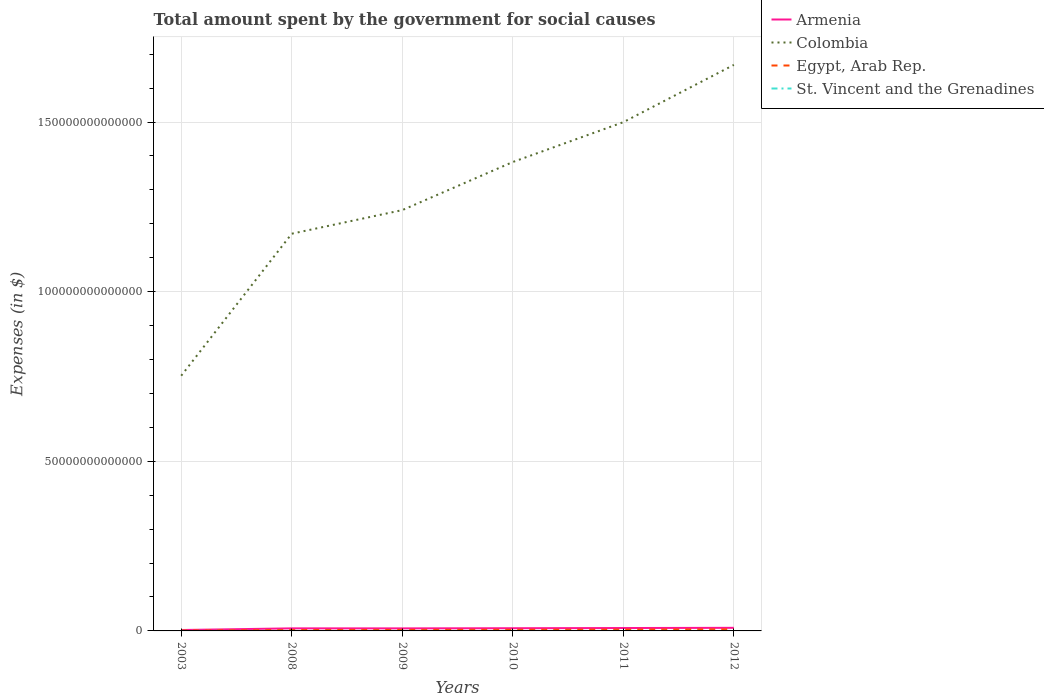Does the line corresponding to Egypt, Arab Rep. intersect with the line corresponding to Armenia?
Provide a succinct answer. No. Is the number of lines equal to the number of legend labels?
Provide a succinct answer. Yes. Across all years, what is the maximum amount spent for social causes by the government in St. Vincent and the Grenadines?
Your response must be concise. 2.72e+08. In which year was the amount spent for social causes by the government in Colombia maximum?
Your answer should be compact. 2003. What is the total amount spent for social causes by the government in Colombia in the graph?
Offer a terse response. -3.29e+13. What is the difference between the highest and the second highest amount spent for social causes by the government in Colombia?
Your answer should be very brief. 9.16e+13. How many lines are there?
Provide a succinct answer. 4. What is the difference between two consecutive major ticks on the Y-axis?
Your response must be concise. 5.00e+13. Does the graph contain grids?
Your answer should be very brief. Yes. Where does the legend appear in the graph?
Provide a succinct answer. Top right. How are the legend labels stacked?
Ensure brevity in your answer.  Vertical. What is the title of the graph?
Provide a short and direct response. Total amount spent by the government for social causes. What is the label or title of the Y-axis?
Ensure brevity in your answer.  Expenses (in $). What is the Expenses (in $) of Armenia in 2003?
Your answer should be compact. 2.67e+11. What is the Expenses (in $) in Colombia in 2003?
Ensure brevity in your answer.  7.52e+13. What is the Expenses (in $) of Egypt, Arab Rep. in 2003?
Offer a very short reply. 1.14e+11. What is the Expenses (in $) in St. Vincent and the Grenadines in 2003?
Provide a succinct answer. 2.72e+08. What is the Expenses (in $) of Armenia in 2008?
Give a very brief answer. 7.54e+11. What is the Expenses (in $) of Colombia in 2008?
Your answer should be compact. 1.17e+14. What is the Expenses (in $) of Egypt, Arab Rep. in 2008?
Make the answer very short. 2.71e+11. What is the Expenses (in $) of St. Vincent and the Grenadines in 2008?
Ensure brevity in your answer.  4.31e+08. What is the Expenses (in $) of Armenia in 2009?
Give a very brief answer. 7.50e+11. What is the Expenses (in $) in Colombia in 2009?
Your answer should be compact. 1.24e+14. What is the Expenses (in $) in Egypt, Arab Rep. in 2009?
Ensure brevity in your answer.  3.13e+11. What is the Expenses (in $) of St. Vincent and the Grenadines in 2009?
Your answer should be compact. 4.70e+08. What is the Expenses (in $) in Armenia in 2010?
Your answer should be very brief. 7.96e+11. What is the Expenses (in $) of Colombia in 2010?
Ensure brevity in your answer.  1.38e+14. What is the Expenses (in $) of Egypt, Arab Rep. in 2010?
Your answer should be compact. 3.48e+11. What is the Expenses (in $) in St. Vincent and the Grenadines in 2010?
Offer a very short reply. 4.73e+08. What is the Expenses (in $) in Armenia in 2011?
Provide a succinct answer. 8.53e+11. What is the Expenses (in $) in Colombia in 2011?
Your answer should be compact. 1.50e+14. What is the Expenses (in $) of Egypt, Arab Rep. in 2011?
Offer a very short reply. 4.00e+11. What is the Expenses (in $) in St. Vincent and the Grenadines in 2011?
Your answer should be compact. 4.95e+08. What is the Expenses (in $) in Armenia in 2012?
Make the answer very short. 9.12e+11. What is the Expenses (in $) in Colombia in 2012?
Offer a terse response. 1.67e+14. What is the Expenses (in $) in Egypt, Arab Rep. in 2012?
Offer a terse response. 4.80e+11. What is the Expenses (in $) of St. Vincent and the Grenadines in 2012?
Give a very brief answer. 4.89e+08. Across all years, what is the maximum Expenses (in $) in Armenia?
Offer a very short reply. 9.12e+11. Across all years, what is the maximum Expenses (in $) of Colombia?
Your answer should be very brief. 1.67e+14. Across all years, what is the maximum Expenses (in $) of Egypt, Arab Rep.?
Your answer should be very brief. 4.80e+11. Across all years, what is the maximum Expenses (in $) in St. Vincent and the Grenadines?
Provide a succinct answer. 4.95e+08. Across all years, what is the minimum Expenses (in $) in Armenia?
Make the answer very short. 2.67e+11. Across all years, what is the minimum Expenses (in $) of Colombia?
Offer a very short reply. 7.52e+13. Across all years, what is the minimum Expenses (in $) of Egypt, Arab Rep.?
Offer a very short reply. 1.14e+11. Across all years, what is the minimum Expenses (in $) of St. Vincent and the Grenadines?
Provide a succinct answer. 2.72e+08. What is the total Expenses (in $) of Armenia in the graph?
Offer a very short reply. 4.33e+12. What is the total Expenses (in $) of Colombia in the graph?
Provide a succinct answer. 7.71e+14. What is the total Expenses (in $) of Egypt, Arab Rep. in the graph?
Your answer should be very brief. 1.93e+12. What is the total Expenses (in $) in St. Vincent and the Grenadines in the graph?
Offer a terse response. 2.63e+09. What is the difference between the Expenses (in $) of Armenia in 2003 and that in 2008?
Your response must be concise. -4.88e+11. What is the difference between the Expenses (in $) in Colombia in 2003 and that in 2008?
Your response must be concise. -4.19e+13. What is the difference between the Expenses (in $) in Egypt, Arab Rep. in 2003 and that in 2008?
Offer a terse response. -1.57e+11. What is the difference between the Expenses (in $) of St. Vincent and the Grenadines in 2003 and that in 2008?
Provide a short and direct response. -1.58e+08. What is the difference between the Expenses (in $) in Armenia in 2003 and that in 2009?
Keep it short and to the point. -4.83e+11. What is the difference between the Expenses (in $) of Colombia in 2003 and that in 2009?
Keep it short and to the point. -4.88e+13. What is the difference between the Expenses (in $) of Egypt, Arab Rep. in 2003 and that in 2009?
Offer a terse response. -1.99e+11. What is the difference between the Expenses (in $) of St. Vincent and the Grenadines in 2003 and that in 2009?
Make the answer very short. -1.97e+08. What is the difference between the Expenses (in $) of Armenia in 2003 and that in 2010?
Your response must be concise. -5.29e+11. What is the difference between the Expenses (in $) of Colombia in 2003 and that in 2010?
Make the answer very short. -6.30e+13. What is the difference between the Expenses (in $) in Egypt, Arab Rep. in 2003 and that in 2010?
Offer a terse response. -2.34e+11. What is the difference between the Expenses (in $) of St. Vincent and the Grenadines in 2003 and that in 2010?
Provide a short and direct response. -2.01e+08. What is the difference between the Expenses (in $) of Armenia in 2003 and that in 2011?
Offer a terse response. -5.86e+11. What is the difference between the Expenses (in $) of Colombia in 2003 and that in 2011?
Offer a very short reply. -7.47e+13. What is the difference between the Expenses (in $) of Egypt, Arab Rep. in 2003 and that in 2011?
Make the answer very short. -2.86e+11. What is the difference between the Expenses (in $) in St. Vincent and the Grenadines in 2003 and that in 2011?
Give a very brief answer. -2.23e+08. What is the difference between the Expenses (in $) in Armenia in 2003 and that in 2012?
Provide a succinct answer. -6.45e+11. What is the difference between the Expenses (in $) of Colombia in 2003 and that in 2012?
Keep it short and to the point. -9.16e+13. What is the difference between the Expenses (in $) in Egypt, Arab Rep. in 2003 and that in 2012?
Keep it short and to the point. -3.66e+11. What is the difference between the Expenses (in $) in St. Vincent and the Grenadines in 2003 and that in 2012?
Make the answer very short. -2.16e+08. What is the difference between the Expenses (in $) of Armenia in 2008 and that in 2009?
Provide a succinct answer. 4.65e+09. What is the difference between the Expenses (in $) of Colombia in 2008 and that in 2009?
Keep it short and to the point. -6.96e+12. What is the difference between the Expenses (in $) in Egypt, Arab Rep. in 2008 and that in 2009?
Give a very brief answer. -4.20e+1. What is the difference between the Expenses (in $) of St. Vincent and the Grenadines in 2008 and that in 2009?
Your answer should be compact. -3.90e+07. What is the difference between the Expenses (in $) in Armenia in 2008 and that in 2010?
Ensure brevity in your answer.  -4.14e+1. What is the difference between the Expenses (in $) in Colombia in 2008 and that in 2010?
Offer a very short reply. -2.11e+13. What is the difference between the Expenses (in $) in Egypt, Arab Rep. in 2008 and that in 2010?
Keep it short and to the point. -7.67e+1. What is the difference between the Expenses (in $) in St. Vincent and the Grenadines in 2008 and that in 2010?
Give a very brief answer. -4.24e+07. What is the difference between the Expenses (in $) of Armenia in 2008 and that in 2011?
Your response must be concise. -9.83e+1. What is the difference between the Expenses (in $) of Colombia in 2008 and that in 2011?
Offer a very short reply. -3.29e+13. What is the difference between the Expenses (in $) of Egypt, Arab Rep. in 2008 and that in 2011?
Your response must be concise. -1.29e+11. What is the difference between the Expenses (in $) in St. Vincent and the Grenadines in 2008 and that in 2011?
Give a very brief answer. -6.44e+07. What is the difference between the Expenses (in $) of Armenia in 2008 and that in 2012?
Ensure brevity in your answer.  -1.58e+11. What is the difference between the Expenses (in $) of Colombia in 2008 and that in 2012?
Your response must be concise. -4.98e+13. What is the difference between the Expenses (in $) of Egypt, Arab Rep. in 2008 and that in 2012?
Make the answer very short. -2.09e+11. What is the difference between the Expenses (in $) of St. Vincent and the Grenadines in 2008 and that in 2012?
Make the answer very short. -5.81e+07. What is the difference between the Expenses (in $) of Armenia in 2009 and that in 2010?
Provide a short and direct response. -4.61e+1. What is the difference between the Expenses (in $) of Colombia in 2009 and that in 2010?
Your response must be concise. -1.42e+13. What is the difference between the Expenses (in $) in Egypt, Arab Rep. in 2009 and that in 2010?
Provide a succinct answer. -3.48e+1. What is the difference between the Expenses (in $) in St. Vincent and the Grenadines in 2009 and that in 2010?
Keep it short and to the point. -3.40e+06. What is the difference between the Expenses (in $) of Armenia in 2009 and that in 2011?
Provide a succinct answer. -1.03e+11. What is the difference between the Expenses (in $) in Colombia in 2009 and that in 2011?
Ensure brevity in your answer.  -2.59e+13. What is the difference between the Expenses (in $) in Egypt, Arab Rep. in 2009 and that in 2011?
Your answer should be very brief. -8.68e+1. What is the difference between the Expenses (in $) in St. Vincent and the Grenadines in 2009 and that in 2011?
Your answer should be compact. -2.54e+07. What is the difference between the Expenses (in $) of Armenia in 2009 and that in 2012?
Offer a terse response. -1.62e+11. What is the difference between the Expenses (in $) in Colombia in 2009 and that in 2012?
Your response must be concise. -4.28e+13. What is the difference between the Expenses (in $) of Egypt, Arab Rep. in 2009 and that in 2012?
Give a very brief answer. -1.67e+11. What is the difference between the Expenses (in $) in St. Vincent and the Grenadines in 2009 and that in 2012?
Make the answer very short. -1.91e+07. What is the difference between the Expenses (in $) of Armenia in 2010 and that in 2011?
Your answer should be very brief. -5.69e+1. What is the difference between the Expenses (in $) of Colombia in 2010 and that in 2011?
Offer a terse response. -1.17e+13. What is the difference between the Expenses (in $) of Egypt, Arab Rep. in 2010 and that in 2011?
Offer a very short reply. -5.20e+1. What is the difference between the Expenses (in $) of St. Vincent and the Grenadines in 2010 and that in 2011?
Ensure brevity in your answer.  -2.20e+07. What is the difference between the Expenses (in $) in Armenia in 2010 and that in 2012?
Your answer should be very brief. -1.16e+11. What is the difference between the Expenses (in $) of Colombia in 2010 and that in 2012?
Give a very brief answer. -2.86e+13. What is the difference between the Expenses (in $) in Egypt, Arab Rep. in 2010 and that in 2012?
Your response must be concise. -1.32e+11. What is the difference between the Expenses (in $) in St. Vincent and the Grenadines in 2010 and that in 2012?
Your answer should be very brief. -1.57e+07. What is the difference between the Expenses (in $) of Armenia in 2011 and that in 2012?
Provide a succinct answer. -5.93e+1. What is the difference between the Expenses (in $) of Colombia in 2011 and that in 2012?
Your response must be concise. -1.69e+13. What is the difference between the Expenses (in $) of Egypt, Arab Rep. in 2011 and that in 2012?
Your answer should be very brief. -8.02e+1. What is the difference between the Expenses (in $) in St. Vincent and the Grenadines in 2011 and that in 2012?
Offer a terse response. 6.30e+06. What is the difference between the Expenses (in $) in Armenia in 2003 and the Expenses (in $) in Colombia in 2008?
Your response must be concise. -1.17e+14. What is the difference between the Expenses (in $) in Armenia in 2003 and the Expenses (in $) in Egypt, Arab Rep. in 2008?
Your response must be concise. -4.82e+09. What is the difference between the Expenses (in $) of Armenia in 2003 and the Expenses (in $) of St. Vincent and the Grenadines in 2008?
Your answer should be compact. 2.66e+11. What is the difference between the Expenses (in $) in Colombia in 2003 and the Expenses (in $) in Egypt, Arab Rep. in 2008?
Keep it short and to the point. 7.50e+13. What is the difference between the Expenses (in $) in Colombia in 2003 and the Expenses (in $) in St. Vincent and the Grenadines in 2008?
Provide a succinct answer. 7.52e+13. What is the difference between the Expenses (in $) of Egypt, Arab Rep. in 2003 and the Expenses (in $) of St. Vincent and the Grenadines in 2008?
Offer a very short reply. 1.14e+11. What is the difference between the Expenses (in $) in Armenia in 2003 and the Expenses (in $) in Colombia in 2009?
Your answer should be compact. -1.24e+14. What is the difference between the Expenses (in $) of Armenia in 2003 and the Expenses (in $) of Egypt, Arab Rep. in 2009?
Ensure brevity in your answer.  -4.68e+1. What is the difference between the Expenses (in $) in Armenia in 2003 and the Expenses (in $) in St. Vincent and the Grenadines in 2009?
Provide a short and direct response. 2.66e+11. What is the difference between the Expenses (in $) in Colombia in 2003 and the Expenses (in $) in Egypt, Arab Rep. in 2009?
Give a very brief answer. 7.49e+13. What is the difference between the Expenses (in $) of Colombia in 2003 and the Expenses (in $) of St. Vincent and the Grenadines in 2009?
Offer a terse response. 7.52e+13. What is the difference between the Expenses (in $) in Egypt, Arab Rep. in 2003 and the Expenses (in $) in St. Vincent and the Grenadines in 2009?
Make the answer very short. 1.14e+11. What is the difference between the Expenses (in $) of Armenia in 2003 and the Expenses (in $) of Colombia in 2010?
Your answer should be very brief. -1.38e+14. What is the difference between the Expenses (in $) in Armenia in 2003 and the Expenses (in $) in Egypt, Arab Rep. in 2010?
Provide a short and direct response. -8.15e+1. What is the difference between the Expenses (in $) in Armenia in 2003 and the Expenses (in $) in St. Vincent and the Grenadines in 2010?
Make the answer very short. 2.66e+11. What is the difference between the Expenses (in $) of Colombia in 2003 and the Expenses (in $) of Egypt, Arab Rep. in 2010?
Provide a succinct answer. 7.49e+13. What is the difference between the Expenses (in $) in Colombia in 2003 and the Expenses (in $) in St. Vincent and the Grenadines in 2010?
Provide a succinct answer. 7.52e+13. What is the difference between the Expenses (in $) of Egypt, Arab Rep. in 2003 and the Expenses (in $) of St. Vincent and the Grenadines in 2010?
Provide a succinct answer. 1.14e+11. What is the difference between the Expenses (in $) in Armenia in 2003 and the Expenses (in $) in Colombia in 2011?
Provide a succinct answer. -1.50e+14. What is the difference between the Expenses (in $) in Armenia in 2003 and the Expenses (in $) in Egypt, Arab Rep. in 2011?
Your response must be concise. -1.34e+11. What is the difference between the Expenses (in $) of Armenia in 2003 and the Expenses (in $) of St. Vincent and the Grenadines in 2011?
Offer a very short reply. 2.66e+11. What is the difference between the Expenses (in $) of Colombia in 2003 and the Expenses (in $) of Egypt, Arab Rep. in 2011?
Ensure brevity in your answer.  7.48e+13. What is the difference between the Expenses (in $) of Colombia in 2003 and the Expenses (in $) of St. Vincent and the Grenadines in 2011?
Your answer should be compact. 7.52e+13. What is the difference between the Expenses (in $) in Egypt, Arab Rep. in 2003 and the Expenses (in $) in St. Vincent and the Grenadines in 2011?
Your response must be concise. 1.14e+11. What is the difference between the Expenses (in $) in Armenia in 2003 and the Expenses (in $) in Colombia in 2012?
Provide a succinct answer. -1.67e+14. What is the difference between the Expenses (in $) in Armenia in 2003 and the Expenses (in $) in Egypt, Arab Rep. in 2012?
Give a very brief answer. -2.14e+11. What is the difference between the Expenses (in $) of Armenia in 2003 and the Expenses (in $) of St. Vincent and the Grenadines in 2012?
Your response must be concise. 2.66e+11. What is the difference between the Expenses (in $) in Colombia in 2003 and the Expenses (in $) in Egypt, Arab Rep. in 2012?
Make the answer very short. 7.47e+13. What is the difference between the Expenses (in $) in Colombia in 2003 and the Expenses (in $) in St. Vincent and the Grenadines in 2012?
Ensure brevity in your answer.  7.52e+13. What is the difference between the Expenses (in $) of Egypt, Arab Rep. in 2003 and the Expenses (in $) of St. Vincent and the Grenadines in 2012?
Offer a very short reply. 1.14e+11. What is the difference between the Expenses (in $) in Armenia in 2008 and the Expenses (in $) in Colombia in 2009?
Your answer should be very brief. -1.23e+14. What is the difference between the Expenses (in $) in Armenia in 2008 and the Expenses (in $) in Egypt, Arab Rep. in 2009?
Provide a short and direct response. 4.41e+11. What is the difference between the Expenses (in $) in Armenia in 2008 and the Expenses (in $) in St. Vincent and the Grenadines in 2009?
Make the answer very short. 7.54e+11. What is the difference between the Expenses (in $) of Colombia in 2008 and the Expenses (in $) of Egypt, Arab Rep. in 2009?
Keep it short and to the point. 1.17e+14. What is the difference between the Expenses (in $) in Colombia in 2008 and the Expenses (in $) in St. Vincent and the Grenadines in 2009?
Provide a short and direct response. 1.17e+14. What is the difference between the Expenses (in $) of Egypt, Arab Rep. in 2008 and the Expenses (in $) of St. Vincent and the Grenadines in 2009?
Offer a terse response. 2.71e+11. What is the difference between the Expenses (in $) in Armenia in 2008 and the Expenses (in $) in Colombia in 2010?
Offer a terse response. -1.37e+14. What is the difference between the Expenses (in $) in Armenia in 2008 and the Expenses (in $) in Egypt, Arab Rep. in 2010?
Keep it short and to the point. 4.06e+11. What is the difference between the Expenses (in $) in Armenia in 2008 and the Expenses (in $) in St. Vincent and the Grenadines in 2010?
Your answer should be very brief. 7.54e+11. What is the difference between the Expenses (in $) in Colombia in 2008 and the Expenses (in $) in Egypt, Arab Rep. in 2010?
Provide a short and direct response. 1.17e+14. What is the difference between the Expenses (in $) in Colombia in 2008 and the Expenses (in $) in St. Vincent and the Grenadines in 2010?
Your answer should be very brief. 1.17e+14. What is the difference between the Expenses (in $) of Egypt, Arab Rep. in 2008 and the Expenses (in $) of St. Vincent and the Grenadines in 2010?
Provide a succinct answer. 2.71e+11. What is the difference between the Expenses (in $) in Armenia in 2008 and the Expenses (in $) in Colombia in 2011?
Keep it short and to the point. -1.49e+14. What is the difference between the Expenses (in $) in Armenia in 2008 and the Expenses (in $) in Egypt, Arab Rep. in 2011?
Provide a succinct answer. 3.54e+11. What is the difference between the Expenses (in $) of Armenia in 2008 and the Expenses (in $) of St. Vincent and the Grenadines in 2011?
Your response must be concise. 7.54e+11. What is the difference between the Expenses (in $) in Colombia in 2008 and the Expenses (in $) in Egypt, Arab Rep. in 2011?
Provide a succinct answer. 1.17e+14. What is the difference between the Expenses (in $) of Colombia in 2008 and the Expenses (in $) of St. Vincent and the Grenadines in 2011?
Your answer should be compact. 1.17e+14. What is the difference between the Expenses (in $) in Egypt, Arab Rep. in 2008 and the Expenses (in $) in St. Vincent and the Grenadines in 2011?
Provide a short and direct response. 2.71e+11. What is the difference between the Expenses (in $) of Armenia in 2008 and the Expenses (in $) of Colombia in 2012?
Your answer should be very brief. -1.66e+14. What is the difference between the Expenses (in $) in Armenia in 2008 and the Expenses (in $) in Egypt, Arab Rep. in 2012?
Provide a succinct answer. 2.74e+11. What is the difference between the Expenses (in $) in Armenia in 2008 and the Expenses (in $) in St. Vincent and the Grenadines in 2012?
Keep it short and to the point. 7.54e+11. What is the difference between the Expenses (in $) in Colombia in 2008 and the Expenses (in $) in Egypt, Arab Rep. in 2012?
Your answer should be very brief. 1.17e+14. What is the difference between the Expenses (in $) of Colombia in 2008 and the Expenses (in $) of St. Vincent and the Grenadines in 2012?
Offer a very short reply. 1.17e+14. What is the difference between the Expenses (in $) in Egypt, Arab Rep. in 2008 and the Expenses (in $) in St. Vincent and the Grenadines in 2012?
Provide a short and direct response. 2.71e+11. What is the difference between the Expenses (in $) in Armenia in 2009 and the Expenses (in $) in Colombia in 2010?
Your response must be concise. -1.37e+14. What is the difference between the Expenses (in $) in Armenia in 2009 and the Expenses (in $) in Egypt, Arab Rep. in 2010?
Your answer should be compact. 4.01e+11. What is the difference between the Expenses (in $) of Armenia in 2009 and the Expenses (in $) of St. Vincent and the Grenadines in 2010?
Provide a short and direct response. 7.49e+11. What is the difference between the Expenses (in $) in Colombia in 2009 and the Expenses (in $) in Egypt, Arab Rep. in 2010?
Provide a short and direct response. 1.24e+14. What is the difference between the Expenses (in $) of Colombia in 2009 and the Expenses (in $) of St. Vincent and the Grenadines in 2010?
Provide a succinct answer. 1.24e+14. What is the difference between the Expenses (in $) in Egypt, Arab Rep. in 2009 and the Expenses (in $) in St. Vincent and the Grenadines in 2010?
Give a very brief answer. 3.13e+11. What is the difference between the Expenses (in $) of Armenia in 2009 and the Expenses (in $) of Colombia in 2011?
Offer a very short reply. -1.49e+14. What is the difference between the Expenses (in $) in Armenia in 2009 and the Expenses (in $) in Egypt, Arab Rep. in 2011?
Give a very brief answer. 3.49e+11. What is the difference between the Expenses (in $) of Armenia in 2009 and the Expenses (in $) of St. Vincent and the Grenadines in 2011?
Provide a succinct answer. 7.49e+11. What is the difference between the Expenses (in $) of Colombia in 2009 and the Expenses (in $) of Egypt, Arab Rep. in 2011?
Provide a succinct answer. 1.24e+14. What is the difference between the Expenses (in $) in Colombia in 2009 and the Expenses (in $) in St. Vincent and the Grenadines in 2011?
Keep it short and to the point. 1.24e+14. What is the difference between the Expenses (in $) of Egypt, Arab Rep. in 2009 and the Expenses (in $) of St. Vincent and the Grenadines in 2011?
Your answer should be compact. 3.13e+11. What is the difference between the Expenses (in $) in Armenia in 2009 and the Expenses (in $) in Colombia in 2012?
Your answer should be compact. -1.66e+14. What is the difference between the Expenses (in $) of Armenia in 2009 and the Expenses (in $) of Egypt, Arab Rep. in 2012?
Provide a succinct answer. 2.69e+11. What is the difference between the Expenses (in $) in Armenia in 2009 and the Expenses (in $) in St. Vincent and the Grenadines in 2012?
Your answer should be compact. 7.49e+11. What is the difference between the Expenses (in $) of Colombia in 2009 and the Expenses (in $) of Egypt, Arab Rep. in 2012?
Ensure brevity in your answer.  1.24e+14. What is the difference between the Expenses (in $) in Colombia in 2009 and the Expenses (in $) in St. Vincent and the Grenadines in 2012?
Offer a terse response. 1.24e+14. What is the difference between the Expenses (in $) of Egypt, Arab Rep. in 2009 and the Expenses (in $) of St. Vincent and the Grenadines in 2012?
Your response must be concise. 3.13e+11. What is the difference between the Expenses (in $) of Armenia in 2010 and the Expenses (in $) of Colombia in 2011?
Your answer should be very brief. -1.49e+14. What is the difference between the Expenses (in $) in Armenia in 2010 and the Expenses (in $) in Egypt, Arab Rep. in 2011?
Keep it short and to the point. 3.96e+11. What is the difference between the Expenses (in $) in Armenia in 2010 and the Expenses (in $) in St. Vincent and the Grenadines in 2011?
Keep it short and to the point. 7.95e+11. What is the difference between the Expenses (in $) of Colombia in 2010 and the Expenses (in $) of Egypt, Arab Rep. in 2011?
Make the answer very short. 1.38e+14. What is the difference between the Expenses (in $) in Colombia in 2010 and the Expenses (in $) in St. Vincent and the Grenadines in 2011?
Keep it short and to the point. 1.38e+14. What is the difference between the Expenses (in $) of Egypt, Arab Rep. in 2010 and the Expenses (in $) of St. Vincent and the Grenadines in 2011?
Ensure brevity in your answer.  3.48e+11. What is the difference between the Expenses (in $) of Armenia in 2010 and the Expenses (in $) of Colombia in 2012?
Make the answer very short. -1.66e+14. What is the difference between the Expenses (in $) of Armenia in 2010 and the Expenses (in $) of Egypt, Arab Rep. in 2012?
Offer a terse response. 3.15e+11. What is the difference between the Expenses (in $) of Armenia in 2010 and the Expenses (in $) of St. Vincent and the Grenadines in 2012?
Ensure brevity in your answer.  7.95e+11. What is the difference between the Expenses (in $) of Colombia in 2010 and the Expenses (in $) of Egypt, Arab Rep. in 2012?
Your answer should be compact. 1.38e+14. What is the difference between the Expenses (in $) of Colombia in 2010 and the Expenses (in $) of St. Vincent and the Grenadines in 2012?
Make the answer very short. 1.38e+14. What is the difference between the Expenses (in $) in Egypt, Arab Rep. in 2010 and the Expenses (in $) in St. Vincent and the Grenadines in 2012?
Ensure brevity in your answer.  3.48e+11. What is the difference between the Expenses (in $) of Armenia in 2011 and the Expenses (in $) of Colombia in 2012?
Your answer should be very brief. -1.66e+14. What is the difference between the Expenses (in $) in Armenia in 2011 and the Expenses (in $) in Egypt, Arab Rep. in 2012?
Offer a terse response. 3.72e+11. What is the difference between the Expenses (in $) in Armenia in 2011 and the Expenses (in $) in St. Vincent and the Grenadines in 2012?
Provide a short and direct response. 8.52e+11. What is the difference between the Expenses (in $) of Colombia in 2011 and the Expenses (in $) of Egypt, Arab Rep. in 2012?
Offer a very short reply. 1.49e+14. What is the difference between the Expenses (in $) of Colombia in 2011 and the Expenses (in $) of St. Vincent and the Grenadines in 2012?
Make the answer very short. 1.50e+14. What is the difference between the Expenses (in $) in Egypt, Arab Rep. in 2011 and the Expenses (in $) in St. Vincent and the Grenadines in 2012?
Make the answer very short. 4.00e+11. What is the average Expenses (in $) in Armenia per year?
Make the answer very short. 7.22e+11. What is the average Expenses (in $) of Colombia per year?
Your answer should be compact. 1.29e+14. What is the average Expenses (in $) of Egypt, Arab Rep. per year?
Offer a very short reply. 3.21e+11. What is the average Expenses (in $) of St. Vincent and the Grenadines per year?
Offer a very short reply. 4.38e+08. In the year 2003, what is the difference between the Expenses (in $) of Armenia and Expenses (in $) of Colombia?
Ensure brevity in your answer.  -7.50e+13. In the year 2003, what is the difference between the Expenses (in $) in Armenia and Expenses (in $) in Egypt, Arab Rep.?
Offer a terse response. 1.53e+11. In the year 2003, what is the difference between the Expenses (in $) of Armenia and Expenses (in $) of St. Vincent and the Grenadines?
Your answer should be very brief. 2.66e+11. In the year 2003, what is the difference between the Expenses (in $) in Colombia and Expenses (in $) in Egypt, Arab Rep.?
Ensure brevity in your answer.  7.51e+13. In the year 2003, what is the difference between the Expenses (in $) of Colombia and Expenses (in $) of St. Vincent and the Grenadines?
Ensure brevity in your answer.  7.52e+13. In the year 2003, what is the difference between the Expenses (in $) of Egypt, Arab Rep. and Expenses (in $) of St. Vincent and the Grenadines?
Keep it short and to the point. 1.14e+11. In the year 2008, what is the difference between the Expenses (in $) of Armenia and Expenses (in $) of Colombia?
Your answer should be compact. -1.16e+14. In the year 2008, what is the difference between the Expenses (in $) in Armenia and Expenses (in $) in Egypt, Arab Rep.?
Offer a very short reply. 4.83e+11. In the year 2008, what is the difference between the Expenses (in $) in Armenia and Expenses (in $) in St. Vincent and the Grenadines?
Provide a short and direct response. 7.54e+11. In the year 2008, what is the difference between the Expenses (in $) of Colombia and Expenses (in $) of Egypt, Arab Rep.?
Your response must be concise. 1.17e+14. In the year 2008, what is the difference between the Expenses (in $) in Colombia and Expenses (in $) in St. Vincent and the Grenadines?
Offer a very short reply. 1.17e+14. In the year 2008, what is the difference between the Expenses (in $) of Egypt, Arab Rep. and Expenses (in $) of St. Vincent and the Grenadines?
Your answer should be very brief. 2.71e+11. In the year 2009, what is the difference between the Expenses (in $) in Armenia and Expenses (in $) in Colombia?
Keep it short and to the point. -1.23e+14. In the year 2009, what is the difference between the Expenses (in $) in Armenia and Expenses (in $) in Egypt, Arab Rep.?
Your answer should be compact. 4.36e+11. In the year 2009, what is the difference between the Expenses (in $) in Armenia and Expenses (in $) in St. Vincent and the Grenadines?
Your answer should be very brief. 7.49e+11. In the year 2009, what is the difference between the Expenses (in $) in Colombia and Expenses (in $) in Egypt, Arab Rep.?
Provide a succinct answer. 1.24e+14. In the year 2009, what is the difference between the Expenses (in $) in Colombia and Expenses (in $) in St. Vincent and the Grenadines?
Offer a very short reply. 1.24e+14. In the year 2009, what is the difference between the Expenses (in $) of Egypt, Arab Rep. and Expenses (in $) of St. Vincent and the Grenadines?
Provide a short and direct response. 3.13e+11. In the year 2010, what is the difference between the Expenses (in $) in Armenia and Expenses (in $) in Colombia?
Give a very brief answer. -1.37e+14. In the year 2010, what is the difference between the Expenses (in $) of Armenia and Expenses (in $) of Egypt, Arab Rep.?
Keep it short and to the point. 4.48e+11. In the year 2010, what is the difference between the Expenses (in $) in Armenia and Expenses (in $) in St. Vincent and the Grenadines?
Offer a terse response. 7.95e+11. In the year 2010, what is the difference between the Expenses (in $) of Colombia and Expenses (in $) of Egypt, Arab Rep.?
Give a very brief answer. 1.38e+14. In the year 2010, what is the difference between the Expenses (in $) in Colombia and Expenses (in $) in St. Vincent and the Grenadines?
Offer a very short reply. 1.38e+14. In the year 2010, what is the difference between the Expenses (in $) in Egypt, Arab Rep. and Expenses (in $) in St. Vincent and the Grenadines?
Keep it short and to the point. 3.48e+11. In the year 2011, what is the difference between the Expenses (in $) in Armenia and Expenses (in $) in Colombia?
Offer a terse response. -1.49e+14. In the year 2011, what is the difference between the Expenses (in $) of Armenia and Expenses (in $) of Egypt, Arab Rep.?
Keep it short and to the point. 4.52e+11. In the year 2011, what is the difference between the Expenses (in $) of Armenia and Expenses (in $) of St. Vincent and the Grenadines?
Provide a short and direct response. 8.52e+11. In the year 2011, what is the difference between the Expenses (in $) in Colombia and Expenses (in $) in Egypt, Arab Rep.?
Offer a terse response. 1.50e+14. In the year 2011, what is the difference between the Expenses (in $) in Colombia and Expenses (in $) in St. Vincent and the Grenadines?
Your answer should be very brief. 1.50e+14. In the year 2011, what is the difference between the Expenses (in $) in Egypt, Arab Rep. and Expenses (in $) in St. Vincent and the Grenadines?
Keep it short and to the point. 4.00e+11. In the year 2012, what is the difference between the Expenses (in $) of Armenia and Expenses (in $) of Colombia?
Your answer should be compact. -1.66e+14. In the year 2012, what is the difference between the Expenses (in $) in Armenia and Expenses (in $) in Egypt, Arab Rep.?
Provide a short and direct response. 4.31e+11. In the year 2012, what is the difference between the Expenses (in $) of Armenia and Expenses (in $) of St. Vincent and the Grenadines?
Provide a short and direct response. 9.11e+11. In the year 2012, what is the difference between the Expenses (in $) of Colombia and Expenses (in $) of Egypt, Arab Rep.?
Your response must be concise. 1.66e+14. In the year 2012, what is the difference between the Expenses (in $) of Colombia and Expenses (in $) of St. Vincent and the Grenadines?
Your answer should be compact. 1.67e+14. In the year 2012, what is the difference between the Expenses (in $) of Egypt, Arab Rep. and Expenses (in $) of St. Vincent and the Grenadines?
Offer a terse response. 4.80e+11. What is the ratio of the Expenses (in $) of Armenia in 2003 to that in 2008?
Keep it short and to the point. 0.35. What is the ratio of the Expenses (in $) of Colombia in 2003 to that in 2008?
Provide a succinct answer. 0.64. What is the ratio of the Expenses (in $) of Egypt, Arab Rep. in 2003 to that in 2008?
Offer a terse response. 0.42. What is the ratio of the Expenses (in $) in St. Vincent and the Grenadines in 2003 to that in 2008?
Provide a short and direct response. 0.63. What is the ratio of the Expenses (in $) of Armenia in 2003 to that in 2009?
Ensure brevity in your answer.  0.36. What is the ratio of the Expenses (in $) in Colombia in 2003 to that in 2009?
Offer a terse response. 0.61. What is the ratio of the Expenses (in $) of Egypt, Arab Rep. in 2003 to that in 2009?
Make the answer very short. 0.36. What is the ratio of the Expenses (in $) in St. Vincent and the Grenadines in 2003 to that in 2009?
Your response must be concise. 0.58. What is the ratio of the Expenses (in $) of Armenia in 2003 to that in 2010?
Your answer should be compact. 0.34. What is the ratio of the Expenses (in $) of Colombia in 2003 to that in 2010?
Provide a short and direct response. 0.54. What is the ratio of the Expenses (in $) of Egypt, Arab Rep. in 2003 to that in 2010?
Give a very brief answer. 0.33. What is the ratio of the Expenses (in $) in St. Vincent and the Grenadines in 2003 to that in 2010?
Make the answer very short. 0.58. What is the ratio of the Expenses (in $) in Armenia in 2003 to that in 2011?
Offer a terse response. 0.31. What is the ratio of the Expenses (in $) of Colombia in 2003 to that in 2011?
Your response must be concise. 0.5. What is the ratio of the Expenses (in $) of Egypt, Arab Rep. in 2003 to that in 2011?
Ensure brevity in your answer.  0.29. What is the ratio of the Expenses (in $) in St. Vincent and the Grenadines in 2003 to that in 2011?
Offer a very short reply. 0.55. What is the ratio of the Expenses (in $) of Armenia in 2003 to that in 2012?
Keep it short and to the point. 0.29. What is the ratio of the Expenses (in $) of Colombia in 2003 to that in 2012?
Provide a short and direct response. 0.45. What is the ratio of the Expenses (in $) in Egypt, Arab Rep. in 2003 to that in 2012?
Your response must be concise. 0.24. What is the ratio of the Expenses (in $) of St. Vincent and the Grenadines in 2003 to that in 2012?
Make the answer very short. 0.56. What is the ratio of the Expenses (in $) of Colombia in 2008 to that in 2009?
Keep it short and to the point. 0.94. What is the ratio of the Expenses (in $) in Egypt, Arab Rep. in 2008 to that in 2009?
Provide a succinct answer. 0.87. What is the ratio of the Expenses (in $) of St. Vincent and the Grenadines in 2008 to that in 2009?
Provide a short and direct response. 0.92. What is the ratio of the Expenses (in $) of Armenia in 2008 to that in 2010?
Offer a very short reply. 0.95. What is the ratio of the Expenses (in $) of Colombia in 2008 to that in 2010?
Make the answer very short. 0.85. What is the ratio of the Expenses (in $) in Egypt, Arab Rep. in 2008 to that in 2010?
Ensure brevity in your answer.  0.78. What is the ratio of the Expenses (in $) in St. Vincent and the Grenadines in 2008 to that in 2010?
Keep it short and to the point. 0.91. What is the ratio of the Expenses (in $) in Armenia in 2008 to that in 2011?
Ensure brevity in your answer.  0.88. What is the ratio of the Expenses (in $) of Colombia in 2008 to that in 2011?
Keep it short and to the point. 0.78. What is the ratio of the Expenses (in $) in Egypt, Arab Rep. in 2008 to that in 2011?
Provide a short and direct response. 0.68. What is the ratio of the Expenses (in $) of St. Vincent and the Grenadines in 2008 to that in 2011?
Your answer should be very brief. 0.87. What is the ratio of the Expenses (in $) of Armenia in 2008 to that in 2012?
Make the answer very short. 0.83. What is the ratio of the Expenses (in $) of Colombia in 2008 to that in 2012?
Provide a succinct answer. 0.7. What is the ratio of the Expenses (in $) of Egypt, Arab Rep. in 2008 to that in 2012?
Provide a succinct answer. 0.57. What is the ratio of the Expenses (in $) of St. Vincent and the Grenadines in 2008 to that in 2012?
Keep it short and to the point. 0.88. What is the ratio of the Expenses (in $) in Armenia in 2009 to that in 2010?
Make the answer very short. 0.94. What is the ratio of the Expenses (in $) of Colombia in 2009 to that in 2010?
Provide a succinct answer. 0.9. What is the ratio of the Expenses (in $) of Egypt, Arab Rep. in 2009 to that in 2010?
Make the answer very short. 0.9. What is the ratio of the Expenses (in $) of Armenia in 2009 to that in 2011?
Provide a short and direct response. 0.88. What is the ratio of the Expenses (in $) of Colombia in 2009 to that in 2011?
Make the answer very short. 0.83. What is the ratio of the Expenses (in $) of Egypt, Arab Rep. in 2009 to that in 2011?
Your response must be concise. 0.78. What is the ratio of the Expenses (in $) in St. Vincent and the Grenadines in 2009 to that in 2011?
Your response must be concise. 0.95. What is the ratio of the Expenses (in $) of Armenia in 2009 to that in 2012?
Offer a terse response. 0.82. What is the ratio of the Expenses (in $) in Colombia in 2009 to that in 2012?
Provide a succinct answer. 0.74. What is the ratio of the Expenses (in $) in Egypt, Arab Rep. in 2009 to that in 2012?
Provide a succinct answer. 0.65. What is the ratio of the Expenses (in $) of St. Vincent and the Grenadines in 2009 to that in 2012?
Your answer should be compact. 0.96. What is the ratio of the Expenses (in $) in Colombia in 2010 to that in 2011?
Your answer should be compact. 0.92. What is the ratio of the Expenses (in $) in Egypt, Arab Rep. in 2010 to that in 2011?
Make the answer very short. 0.87. What is the ratio of the Expenses (in $) of St. Vincent and the Grenadines in 2010 to that in 2011?
Ensure brevity in your answer.  0.96. What is the ratio of the Expenses (in $) in Armenia in 2010 to that in 2012?
Offer a very short reply. 0.87. What is the ratio of the Expenses (in $) of Colombia in 2010 to that in 2012?
Make the answer very short. 0.83. What is the ratio of the Expenses (in $) in Egypt, Arab Rep. in 2010 to that in 2012?
Your answer should be compact. 0.72. What is the ratio of the Expenses (in $) of St. Vincent and the Grenadines in 2010 to that in 2012?
Your answer should be compact. 0.97. What is the ratio of the Expenses (in $) of Armenia in 2011 to that in 2012?
Offer a terse response. 0.94. What is the ratio of the Expenses (in $) of Colombia in 2011 to that in 2012?
Ensure brevity in your answer.  0.9. What is the ratio of the Expenses (in $) of Egypt, Arab Rep. in 2011 to that in 2012?
Provide a succinct answer. 0.83. What is the ratio of the Expenses (in $) in St. Vincent and the Grenadines in 2011 to that in 2012?
Your answer should be compact. 1.01. What is the difference between the highest and the second highest Expenses (in $) in Armenia?
Ensure brevity in your answer.  5.93e+1. What is the difference between the highest and the second highest Expenses (in $) of Colombia?
Keep it short and to the point. 1.69e+13. What is the difference between the highest and the second highest Expenses (in $) in Egypt, Arab Rep.?
Offer a very short reply. 8.02e+1. What is the difference between the highest and the second highest Expenses (in $) of St. Vincent and the Grenadines?
Give a very brief answer. 6.30e+06. What is the difference between the highest and the lowest Expenses (in $) of Armenia?
Offer a terse response. 6.45e+11. What is the difference between the highest and the lowest Expenses (in $) of Colombia?
Keep it short and to the point. 9.16e+13. What is the difference between the highest and the lowest Expenses (in $) in Egypt, Arab Rep.?
Give a very brief answer. 3.66e+11. What is the difference between the highest and the lowest Expenses (in $) in St. Vincent and the Grenadines?
Offer a terse response. 2.23e+08. 